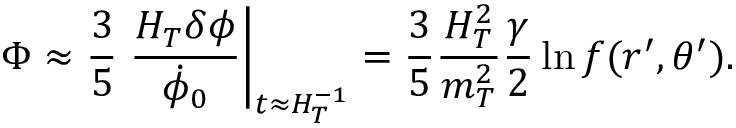Convert formula to latex. <formula><loc_0><loc_0><loc_500><loc_500>\Phi \approx { \frac { 3 } { 5 } } { \frac { H _ { T } \delta \phi } { \dot { \phi } _ { 0 } } } \right | _ { t \approx H _ { T } ^ { - 1 } } = { \frac { 3 } { 5 } } { \frac { H _ { T } ^ { 2 } } { m _ { T } ^ { 2 } } } { \frac { \gamma } { 2 } } \ln f ( r ^ { \prime } , \theta ^ { \prime } ) .</formula> 